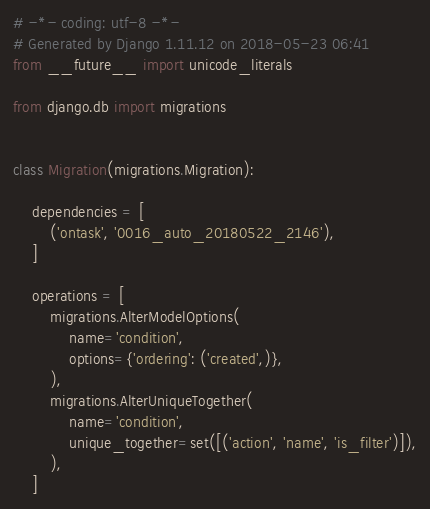Convert code to text. <code><loc_0><loc_0><loc_500><loc_500><_Python_># -*- coding: utf-8 -*-
# Generated by Django 1.11.12 on 2018-05-23 06:41
from __future__ import unicode_literals

from django.db import migrations


class Migration(migrations.Migration):

    dependencies = [
        ('ontask', '0016_auto_20180522_2146'),
    ]

    operations = [
        migrations.AlterModelOptions(
            name='condition',
            options={'ordering': ('created',)},
        ),
        migrations.AlterUniqueTogether(
            name='condition',
            unique_together=set([('action', 'name', 'is_filter')]),
        ),
    ]
</code> 